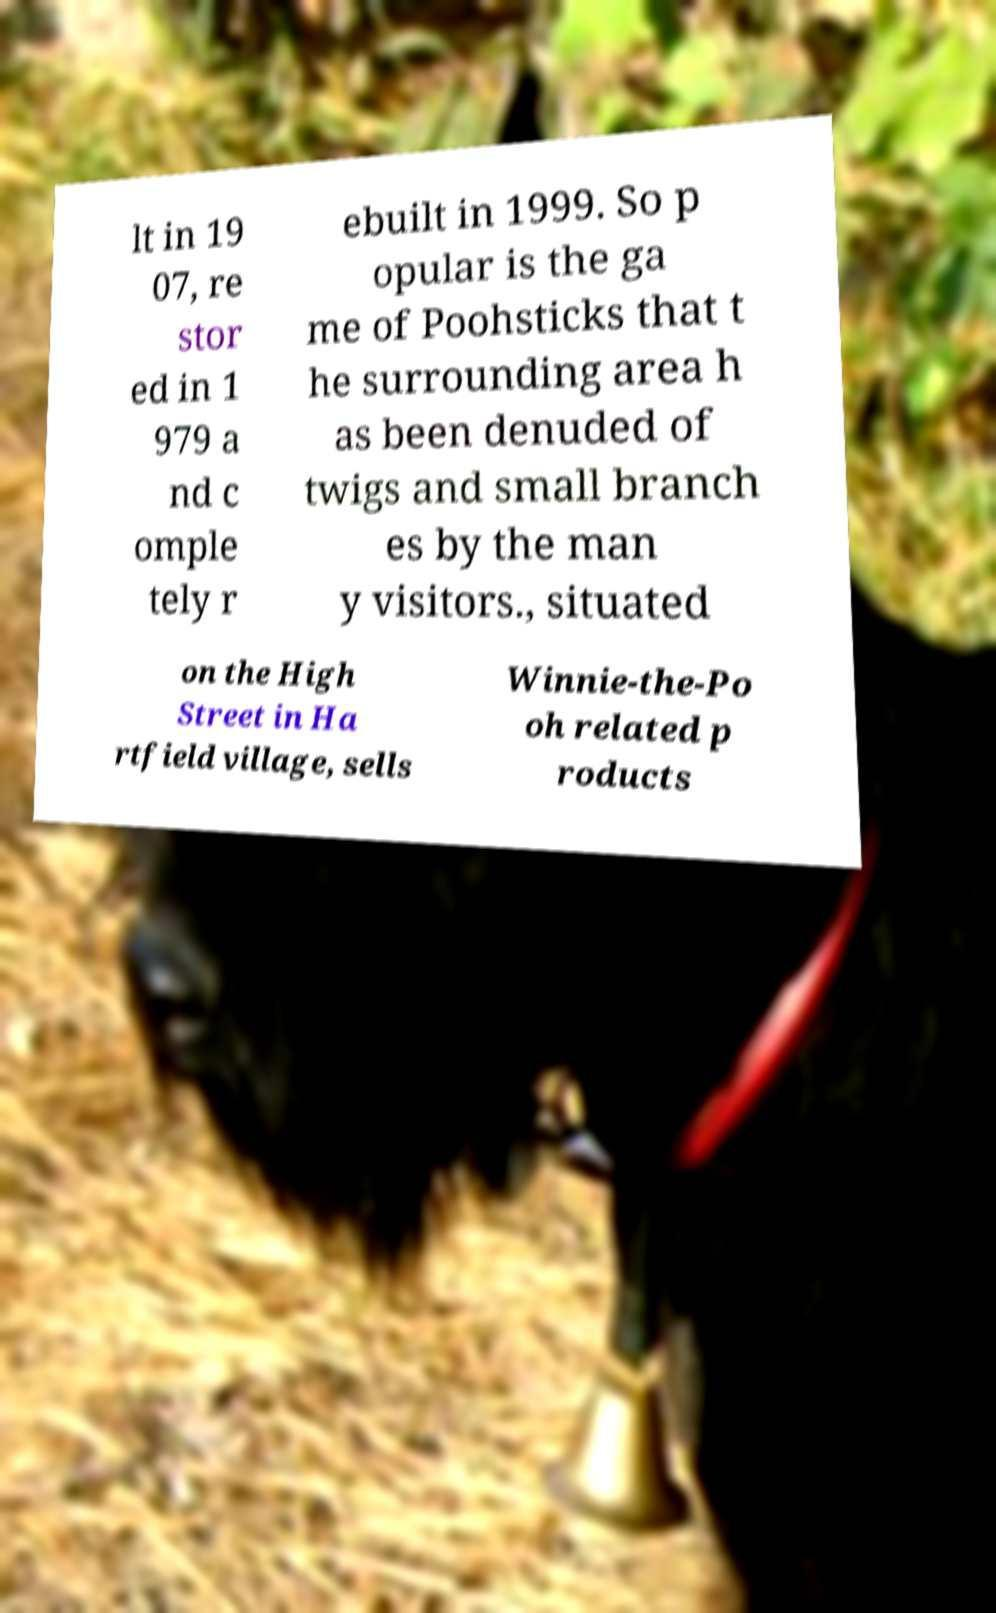Can you accurately transcribe the text from the provided image for me? lt in 19 07, re stor ed in 1 979 a nd c omple tely r ebuilt in 1999. So p opular is the ga me of Poohsticks that t he surrounding area h as been denuded of twigs and small branch es by the man y visitors., situated on the High Street in Ha rtfield village, sells Winnie-the-Po oh related p roducts 